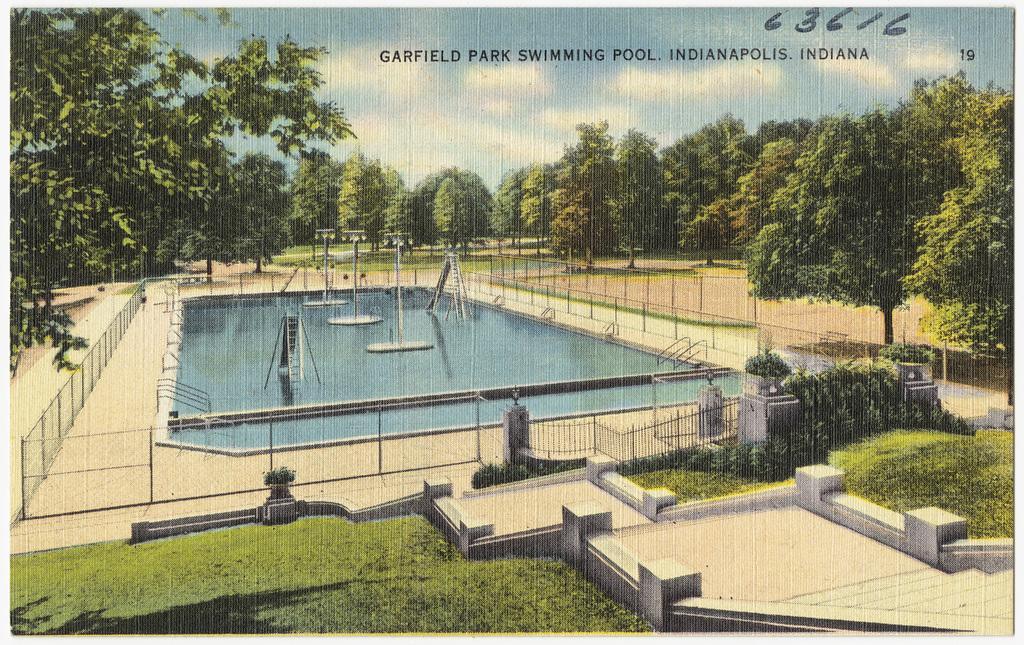How would you summarize this image in a sentence or two? In this image we can see a poster, in that there is a swimming pool, poles, trees, and the sky, also we can see some text on the image. 